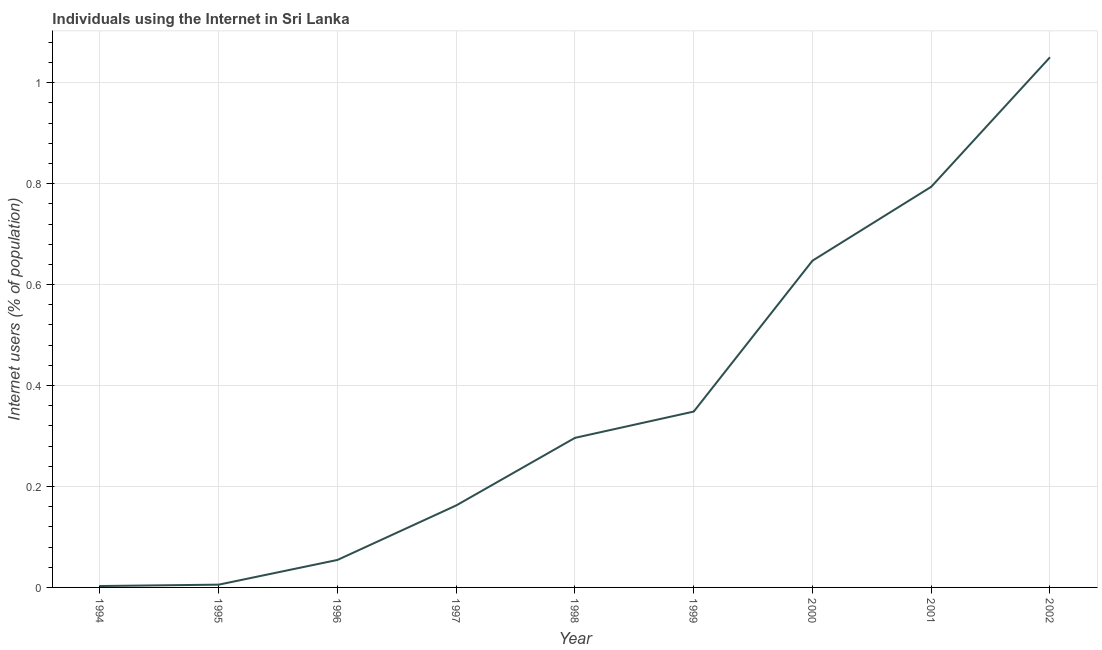What is the number of internet users in 1996?
Make the answer very short. 0.05. Across all years, what is the maximum number of internet users?
Keep it short and to the point. 1.05. Across all years, what is the minimum number of internet users?
Keep it short and to the point. 0. In which year was the number of internet users maximum?
Give a very brief answer. 2002. What is the sum of the number of internet users?
Keep it short and to the point. 3.36. What is the difference between the number of internet users in 1997 and 1999?
Make the answer very short. -0.19. What is the average number of internet users per year?
Offer a terse response. 0.37. What is the median number of internet users?
Provide a succinct answer. 0.3. In how many years, is the number of internet users greater than 0.12 %?
Offer a terse response. 6. Do a majority of the years between 2001 and 1996 (inclusive) have number of internet users greater than 0.36 %?
Offer a very short reply. Yes. What is the ratio of the number of internet users in 1995 to that in 1998?
Provide a short and direct response. 0.02. Is the number of internet users in 1994 less than that in 2000?
Offer a very short reply. Yes. Is the difference between the number of internet users in 1995 and 1999 greater than the difference between any two years?
Offer a very short reply. No. What is the difference between the highest and the second highest number of internet users?
Offer a very short reply. 0.26. What is the difference between the highest and the lowest number of internet users?
Make the answer very short. 1.05. How many lines are there?
Your response must be concise. 1. How many years are there in the graph?
Ensure brevity in your answer.  9. Does the graph contain any zero values?
Keep it short and to the point. No. What is the title of the graph?
Offer a terse response. Individuals using the Internet in Sri Lanka. What is the label or title of the X-axis?
Make the answer very short. Year. What is the label or title of the Y-axis?
Make the answer very short. Internet users (% of population). What is the Internet users (% of population) of 1994?
Make the answer very short. 0. What is the Internet users (% of population) of 1995?
Ensure brevity in your answer.  0.01. What is the Internet users (% of population) of 1996?
Provide a succinct answer. 0.05. What is the Internet users (% of population) of 1997?
Your answer should be very brief. 0.16. What is the Internet users (% of population) in 1998?
Provide a succinct answer. 0.3. What is the Internet users (% of population) in 1999?
Your answer should be very brief. 0.35. What is the Internet users (% of population) in 2000?
Keep it short and to the point. 0.65. What is the Internet users (% of population) of 2001?
Provide a succinct answer. 0.79. What is the Internet users (% of population) in 2002?
Offer a terse response. 1.05. What is the difference between the Internet users (% of population) in 1994 and 1995?
Your answer should be compact. -0. What is the difference between the Internet users (% of population) in 1994 and 1996?
Provide a succinct answer. -0.05. What is the difference between the Internet users (% of population) in 1994 and 1997?
Ensure brevity in your answer.  -0.16. What is the difference between the Internet users (% of population) in 1994 and 1998?
Your answer should be compact. -0.29. What is the difference between the Internet users (% of population) in 1994 and 1999?
Your answer should be compact. -0.35. What is the difference between the Internet users (% of population) in 1994 and 2000?
Your answer should be compact. -0.64. What is the difference between the Internet users (% of population) in 1994 and 2001?
Provide a succinct answer. -0.79. What is the difference between the Internet users (% of population) in 1994 and 2002?
Give a very brief answer. -1.05. What is the difference between the Internet users (% of population) in 1995 and 1996?
Your response must be concise. -0.05. What is the difference between the Internet users (% of population) in 1995 and 1997?
Keep it short and to the point. -0.16. What is the difference between the Internet users (% of population) in 1995 and 1998?
Your response must be concise. -0.29. What is the difference between the Internet users (% of population) in 1995 and 1999?
Make the answer very short. -0.34. What is the difference between the Internet users (% of population) in 1995 and 2000?
Offer a terse response. -0.64. What is the difference between the Internet users (% of population) in 1995 and 2001?
Keep it short and to the point. -0.79. What is the difference between the Internet users (% of population) in 1995 and 2002?
Provide a short and direct response. -1.04. What is the difference between the Internet users (% of population) in 1996 and 1997?
Keep it short and to the point. -0.11. What is the difference between the Internet users (% of population) in 1996 and 1998?
Your answer should be compact. -0.24. What is the difference between the Internet users (% of population) in 1996 and 1999?
Your answer should be compact. -0.29. What is the difference between the Internet users (% of population) in 1996 and 2000?
Keep it short and to the point. -0.59. What is the difference between the Internet users (% of population) in 1996 and 2001?
Your response must be concise. -0.74. What is the difference between the Internet users (% of population) in 1996 and 2002?
Make the answer very short. -1. What is the difference between the Internet users (% of population) in 1997 and 1998?
Ensure brevity in your answer.  -0.13. What is the difference between the Internet users (% of population) in 1997 and 1999?
Provide a short and direct response. -0.19. What is the difference between the Internet users (% of population) in 1997 and 2000?
Give a very brief answer. -0.48. What is the difference between the Internet users (% of population) in 1997 and 2001?
Ensure brevity in your answer.  -0.63. What is the difference between the Internet users (% of population) in 1997 and 2002?
Offer a very short reply. -0.89. What is the difference between the Internet users (% of population) in 1998 and 1999?
Ensure brevity in your answer.  -0.05. What is the difference between the Internet users (% of population) in 1998 and 2000?
Keep it short and to the point. -0.35. What is the difference between the Internet users (% of population) in 1998 and 2001?
Your answer should be very brief. -0.5. What is the difference between the Internet users (% of population) in 1998 and 2002?
Your answer should be compact. -0.75. What is the difference between the Internet users (% of population) in 1999 and 2000?
Give a very brief answer. -0.3. What is the difference between the Internet users (% of population) in 1999 and 2001?
Your answer should be compact. -0.45. What is the difference between the Internet users (% of population) in 1999 and 2002?
Ensure brevity in your answer.  -0.7. What is the difference between the Internet users (% of population) in 2000 and 2001?
Offer a terse response. -0.15. What is the difference between the Internet users (% of population) in 2000 and 2002?
Your response must be concise. -0.4. What is the difference between the Internet users (% of population) in 2001 and 2002?
Make the answer very short. -0.26. What is the ratio of the Internet users (% of population) in 1994 to that in 1995?
Your answer should be very brief. 0.5. What is the ratio of the Internet users (% of population) in 1994 to that in 1996?
Keep it short and to the point. 0.05. What is the ratio of the Internet users (% of population) in 1994 to that in 1997?
Provide a succinct answer. 0.02. What is the ratio of the Internet users (% of population) in 1994 to that in 1998?
Ensure brevity in your answer.  0.01. What is the ratio of the Internet users (% of population) in 1994 to that in 1999?
Make the answer very short. 0.01. What is the ratio of the Internet users (% of population) in 1994 to that in 2000?
Your answer should be very brief. 0. What is the ratio of the Internet users (% of population) in 1994 to that in 2001?
Give a very brief answer. 0. What is the ratio of the Internet users (% of population) in 1994 to that in 2002?
Offer a terse response. 0. What is the ratio of the Internet users (% of population) in 1995 to that in 1996?
Your answer should be very brief. 0.1. What is the ratio of the Internet users (% of population) in 1995 to that in 1997?
Your answer should be compact. 0.03. What is the ratio of the Internet users (% of population) in 1995 to that in 1998?
Your answer should be compact. 0.02. What is the ratio of the Internet users (% of population) in 1995 to that in 1999?
Offer a very short reply. 0.02. What is the ratio of the Internet users (% of population) in 1995 to that in 2000?
Offer a terse response. 0.01. What is the ratio of the Internet users (% of population) in 1995 to that in 2001?
Keep it short and to the point. 0.01. What is the ratio of the Internet users (% of population) in 1995 to that in 2002?
Your response must be concise. 0.01. What is the ratio of the Internet users (% of population) in 1996 to that in 1997?
Ensure brevity in your answer.  0.34. What is the ratio of the Internet users (% of population) in 1996 to that in 1998?
Offer a very short reply. 0.18. What is the ratio of the Internet users (% of population) in 1996 to that in 1999?
Provide a succinct answer. 0.16. What is the ratio of the Internet users (% of population) in 1996 to that in 2000?
Make the answer very short. 0.08. What is the ratio of the Internet users (% of population) in 1996 to that in 2001?
Give a very brief answer. 0.07. What is the ratio of the Internet users (% of population) in 1996 to that in 2002?
Keep it short and to the point. 0.05. What is the ratio of the Internet users (% of population) in 1997 to that in 1998?
Offer a terse response. 0.55. What is the ratio of the Internet users (% of population) in 1997 to that in 1999?
Offer a terse response. 0.47. What is the ratio of the Internet users (% of population) in 1997 to that in 2000?
Ensure brevity in your answer.  0.25. What is the ratio of the Internet users (% of population) in 1997 to that in 2001?
Offer a very short reply. 0.2. What is the ratio of the Internet users (% of population) in 1997 to that in 2002?
Your answer should be very brief. 0.15. What is the ratio of the Internet users (% of population) in 1998 to that in 1999?
Give a very brief answer. 0.85. What is the ratio of the Internet users (% of population) in 1998 to that in 2000?
Provide a short and direct response. 0.46. What is the ratio of the Internet users (% of population) in 1998 to that in 2001?
Ensure brevity in your answer.  0.37. What is the ratio of the Internet users (% of population) in 1998 to that in 2002?
Your answer should be very brief. 0.28. What is the ratio of the Internet users (% of population) in 1999 to that in 2000?
Offer a terse response. 0.54. What is the ratio of the Internet users (% of population) in 1999 to that in 2001?
Your response must be concise. 0.44. What is the ratio of the Internet users (% of population) in 1999 to that in 2002?
Offer a very short reply. 0.33. What is the ratio of the Internet users (% of population) in 2000 to that in 2001?
Provide a short and direct response. 0.82. What is the ratio of the Internet users (% of population) in 2000 to that in 2002?
Keep it short and to the point. 0.62. What is the ratio of the Internet users (% of population) in 2001 to that in 2002?
Ensure brevity in your answer.  0.76. 